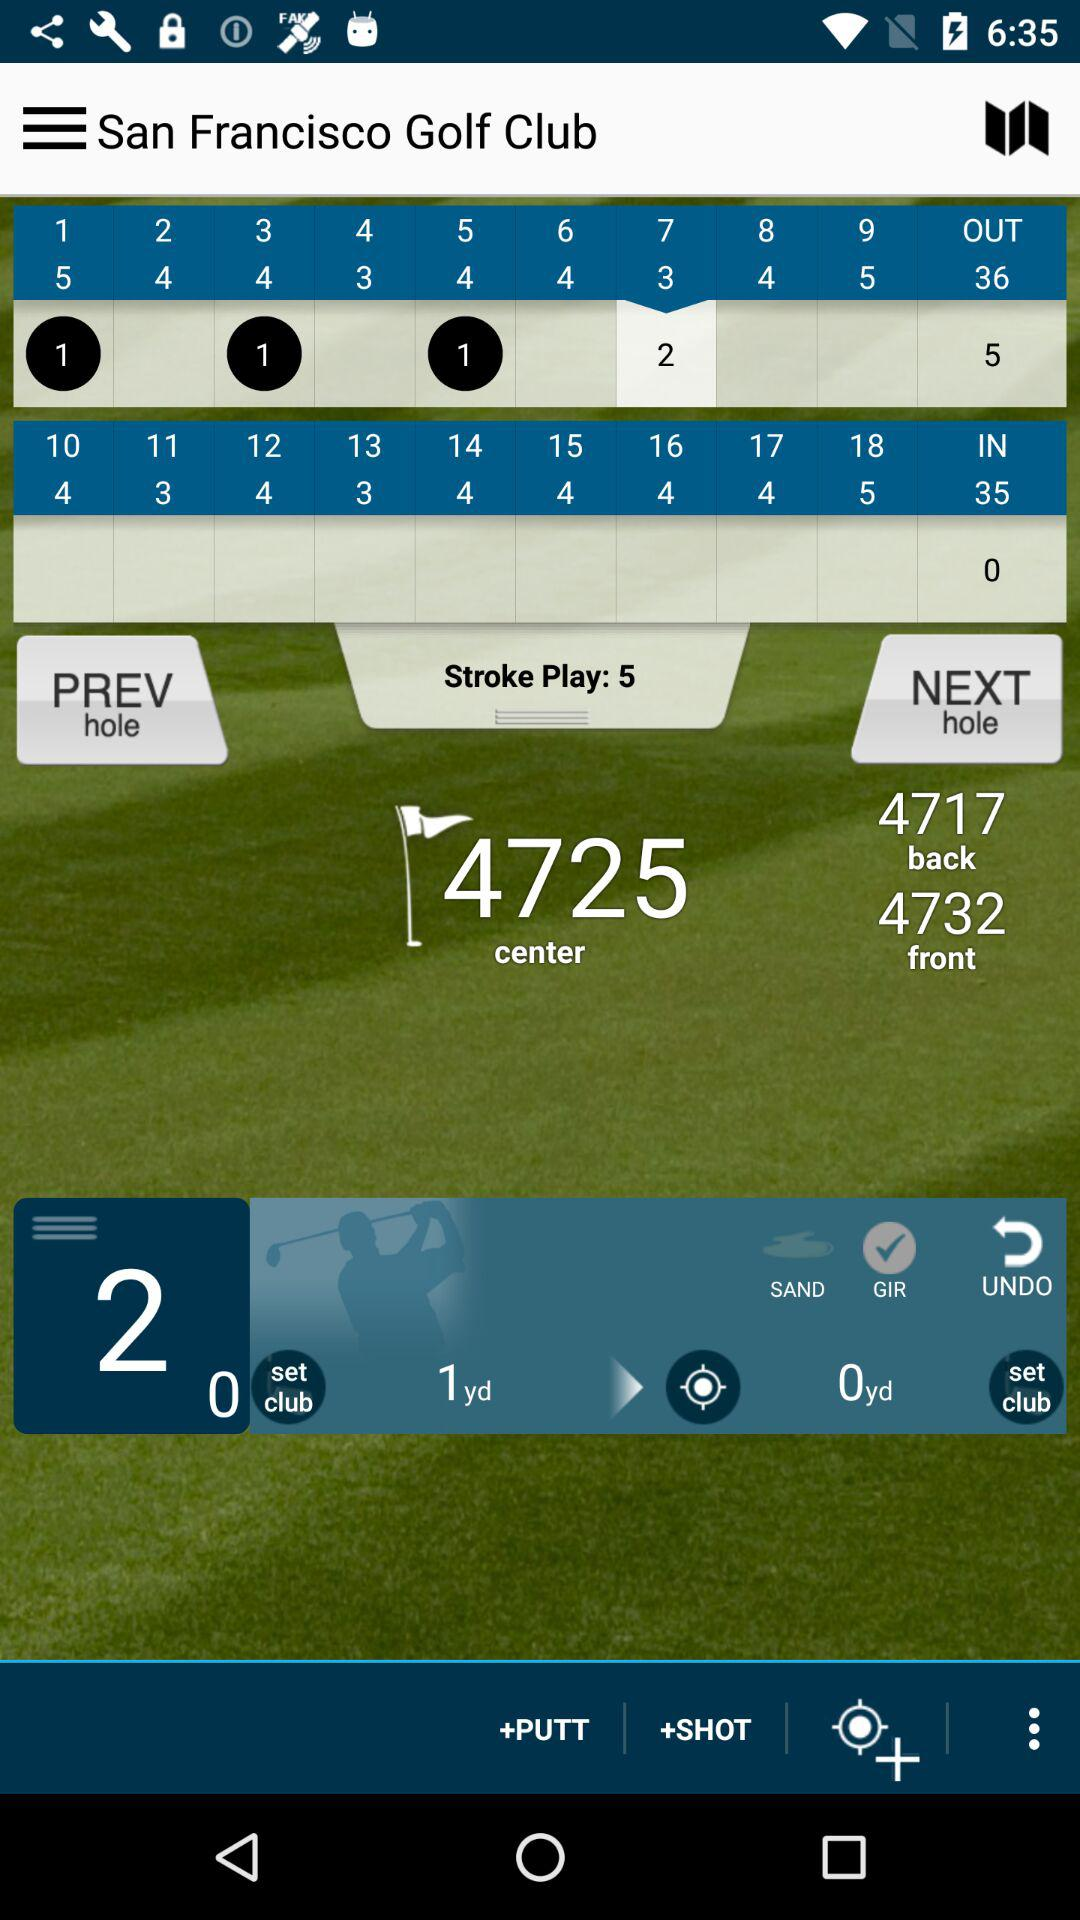What is the number of "Stroke Play"? The number is 5. 